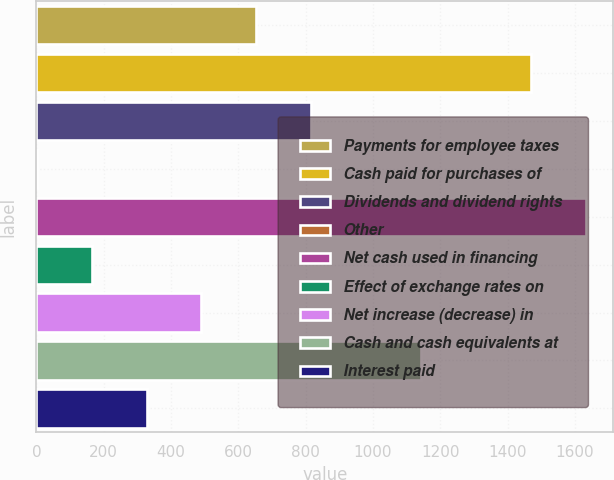Convert chart. <chart><loc_0><loc_0><loc_500><loc_500><bar_chart><fcel>Payments for employee taxes<fcel>Cash paid for purchases of<fcel>Dividends and dividend rights<fcel>Other<fcel>Net cash used in financing<fcel>Effect of exchange rates on<fcel>Net increase (decrease) in<fcel>Cash and cash equivalents at<fcel>Interest paid<nl><fcel>653.4<fcel>1468.9<fcel>816.5<fcel>1<fcel>1632<fcel>164.1<fcel>490.3<fcel>1142.7<fcel>327.2<nl></chart> 